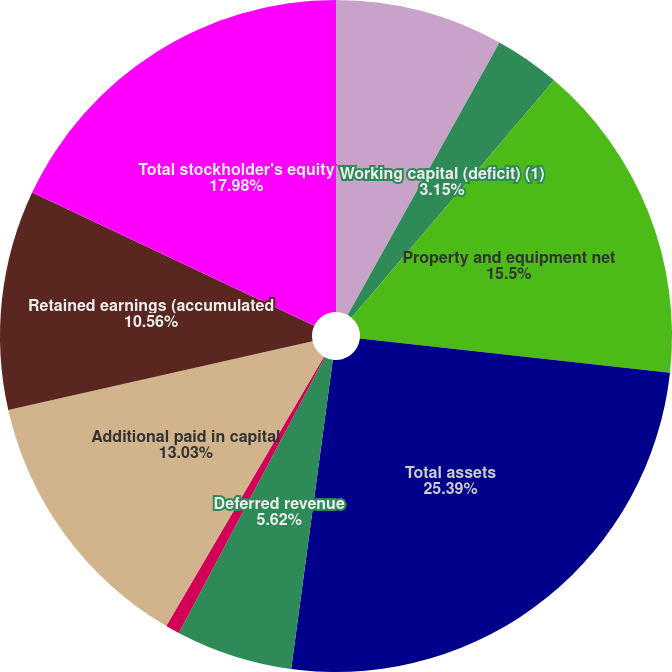<chart> <loc_0><loc_0><loc_500><loc_500><pie_chart><fcel>Cash and cash equivalents<fcel>Working capital (deficit) (1)<fcel>Property and equipment net<fcel>Total assets<fcel>Deferred revenue<fcel>Net long-term debt less<fcel>Additional paid in capital<fcel>Retained earnings (accumulated<fcel>Total stockholder's equity<nl><fcel>8.09%<fcel>3.15%<fcel>15.5%<fcel>25.39%<fcel>5.62%<fcel>0.68%<fcel>13.03%<fcel>10.56%<fcel>17.98%<nl></chart> 